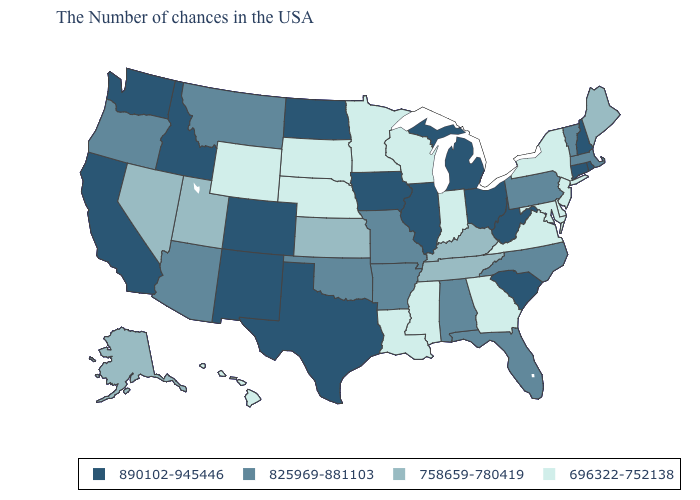Does Maryland have the highest value in the South?
Answer briefly. No. Which states have the lowest value in the MidWest?
Quick response, please. Indiana, Wisconsin, Minnesota, Nebraska, South Dakota. Name the states that have a value in the range 890102-945446?
Answer briefly. Rhode Island, New Hampshire, Connecticut, South Carolina, West Virginia, Ohio, Michigan, Illinois, Iowa, Texas, North Dakota, Colorado, New Mexico, Idaho, California, Washington. Among the states that border Iowa , does Wisconsin have the highest value?
Be succinct. No. What is the value of Alabama?
Answer briefly. 825969-881103. What is the value of Idaho?
Short answer required. 890102-945446. Does Tennessee have the highest value in the South?
Keep it brief. No. Name the states that have a value in the range 890102-945446?
Answer briefly. Rhode Island, New Hampshire, Connecticut, South Carolina, West Virginia, Ohio, Michigan, Illinois, Iowa, Texas, North Dakota, Colorado, New Mexico, Idaho, California, Washington. Name the states that have a value in the range 696322-752138?
Concise answer only. New York, New Jersey, Delaware, Maryland, Virginia, Georgia, Indiana, Wisconsin, Mississippi, Louisiana, Minnesota, Nebraska, South Dakota, Wyoming, Hawaii. Among the states that border Wisconsin , which have the highest value?
Keep it brief. Michigan, Illinois, Iowa. What is the value of Alabama?
Write a very short answer. 825969-881103. Does South Carolina have the highest value in the South?
Write a very short answer. Yes. Which states have the highest value in the USA?
Write a very short answer. Rhode Island, New Hampshire, Connecticut, South Carolina, West Virginia, Ohio, Michigan, Illinois, Iowa, Texas, North Dakota, Colorado, New Mexico, Idaho, California, Washington. What is the lowest value in the USA?
Short answer required. 696322-752138. What is the value of Illinois?
Be succinct. 890102-945446. 